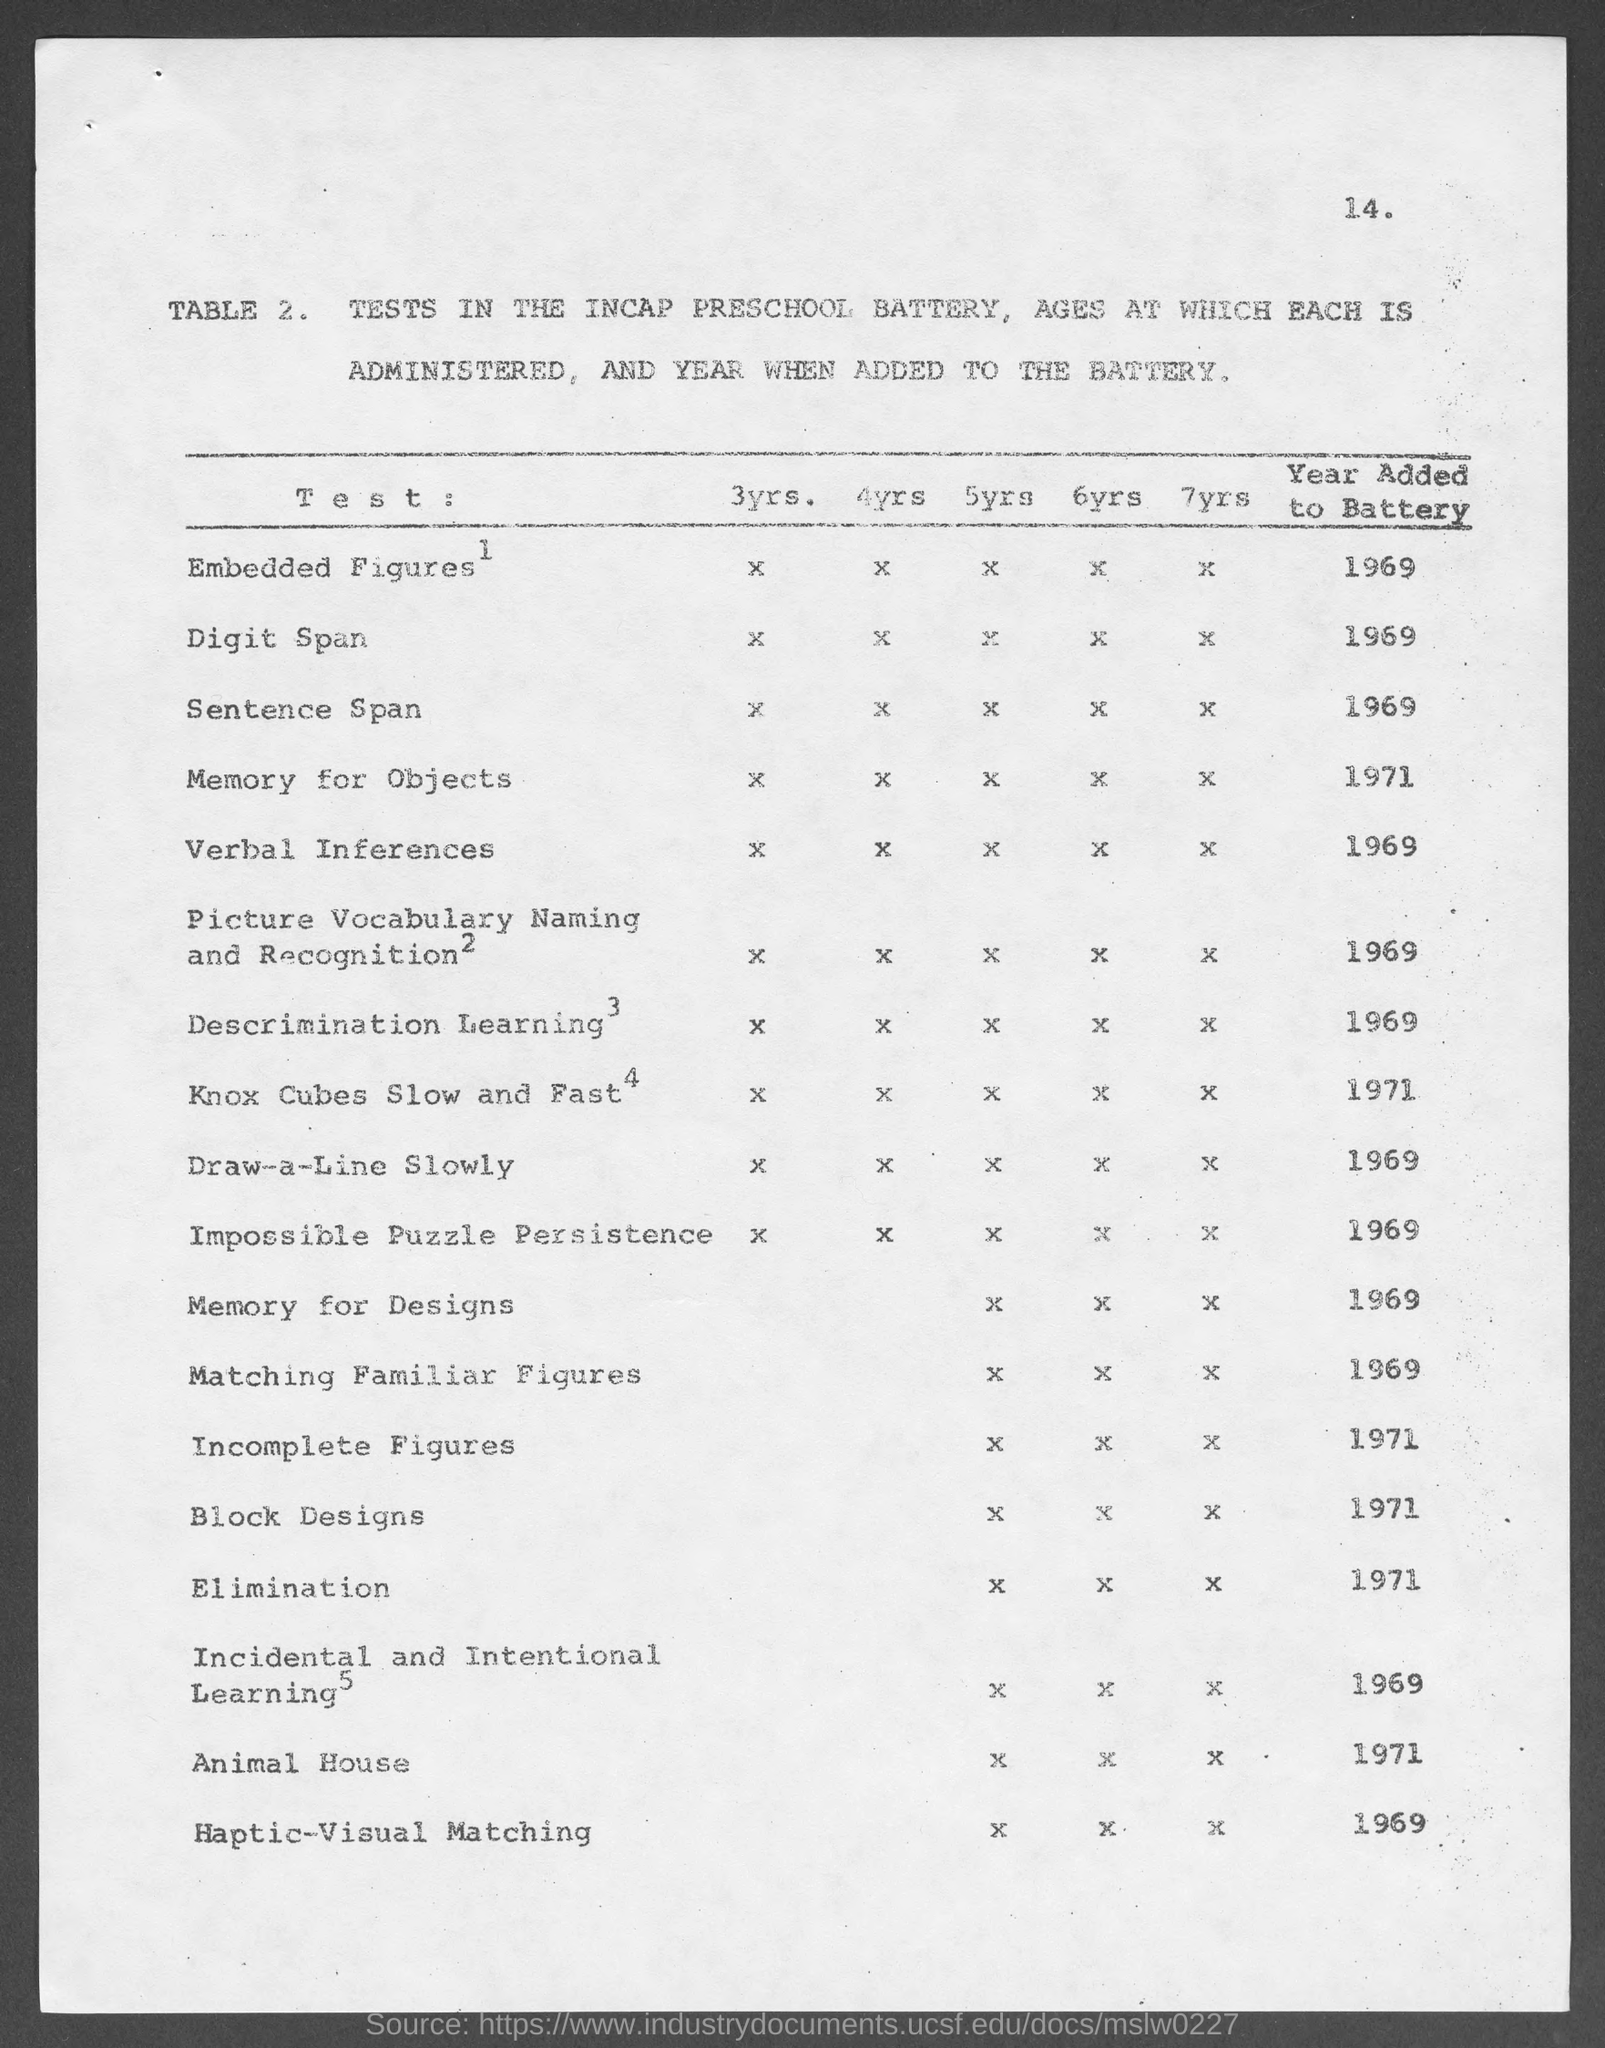What is the table no.?
Give a very brief answer. 2. What is the year added to battery for embedded figures?
Ensure brevity in your answer.  1969. What is the year added to battery for digit span?
Ensure brevity in your answer.  1969. What is the year added to battery for sentence span?
Your answer should be compact. 1969. What is the year added to battery for memory for objects ?
Offer a very short reply. 1971. What is the year added to battery for verbal inferences ?
Keep it short and to the point. 1969. What is the year added to battery for descrimination learning ?
Ensure brevity in your answer.  1969. What is the year added to battery for block designs?
Your response must be concise. 1971. What is the year added to battery for elimination ?
Provide a short and direct response. 1971. What is the year added to battery for animal house?
Give a very brief answer. 1971. 